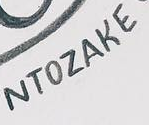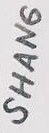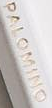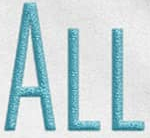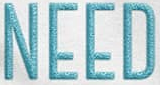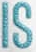Transcribe the words shown in these images in order, separated by a semicolon. NTOZAKE; SHANG; PALOMINO; ALL; NEED; IS 